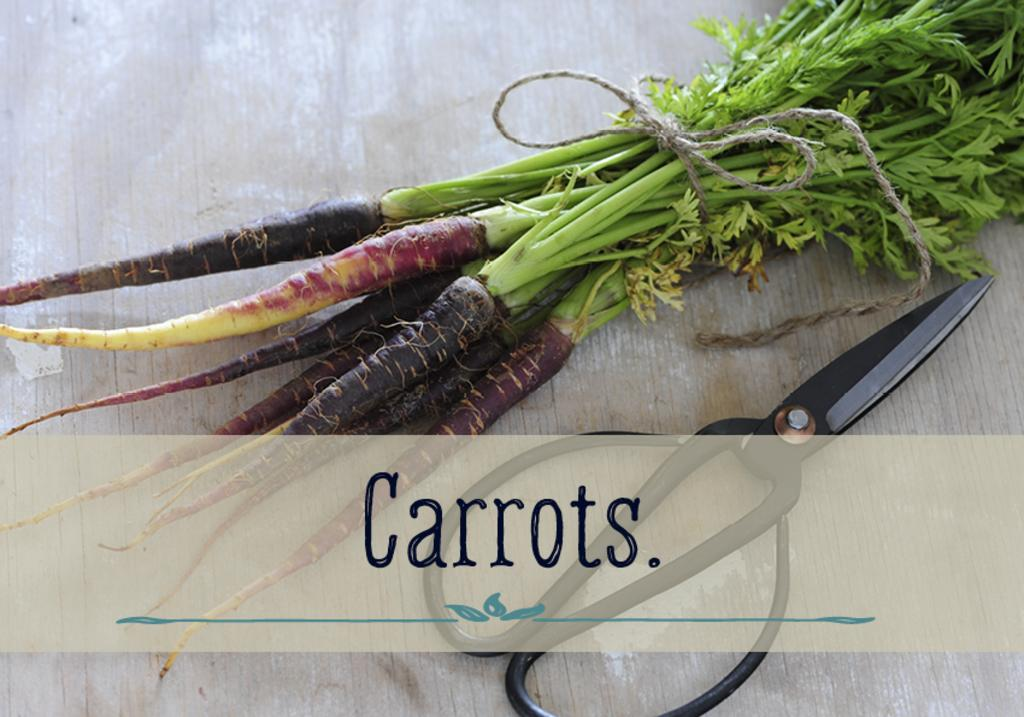What type of vegetable is present in the image? There is a bunch of carrots in the image. What tool is visible in the image? There are scissors in the image. What material is the surface in the image made of? The wooden surface is visible in the image. Can you describe any additional features of the image? There is a watermark at the bottom of the image. What type of fruit is being placed in the bag in the image? There is no fruit or bag present in the image; it only features a bunch of carrots, scissors, and a wooden surface. How does the image convey a good-bye message? The image does not convey a good-bye message; it is a still image with no text or context to suggest a farewell. 